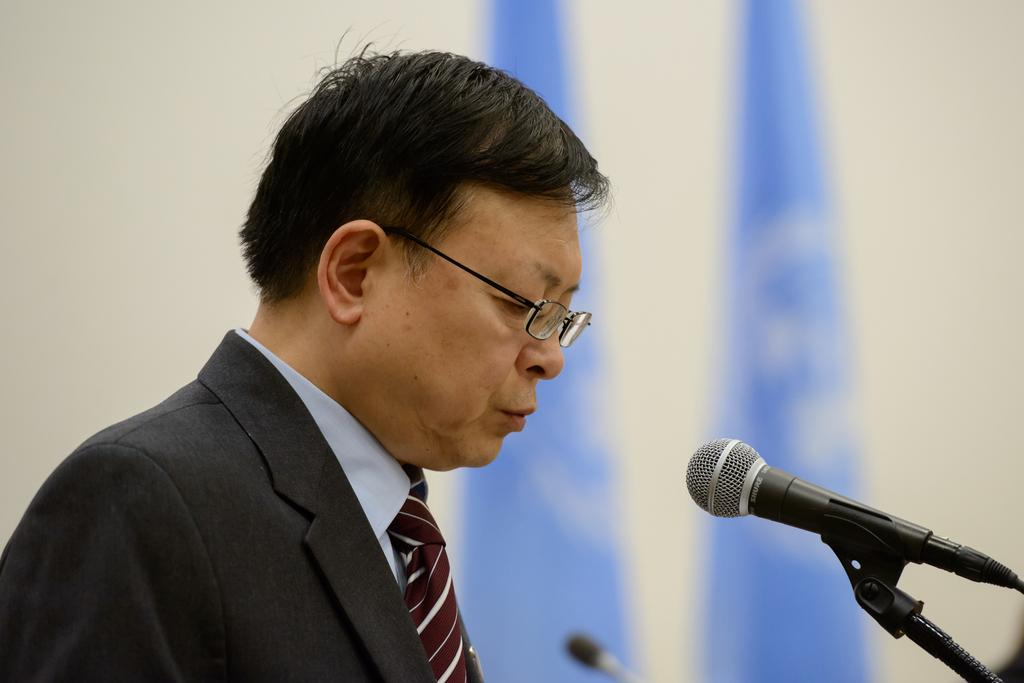Who or what is the main subject in the image? There is a person in the image. What is the person doing in the image? The person is visible in front of a microphone. What is the color of the background in the image? The background of the image is white. Can you see any mountains or snow in the image? No, there are no mountains or snow visible in the image. Is there a crack in the microphone in the image? There is no crack in the microphone visible in the image. 